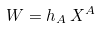Convert formula to latex. <formula><loc_0><loc_0><loc_500><loc_500>W = h _ { A } \, X ^ { A }</formula> 